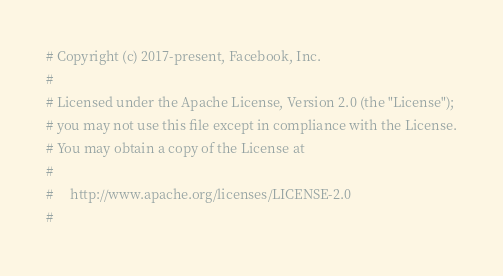<code> <loc_0><loc_0><loc_500><loc_500><_Python_># Copyright (c) 2017-present, Facebook, Inc.
#
# Licensed under the Apache License, Version 2.0 (the "License");
# you may not use this file except in compliance with the License.
# You may obtain a copy of the License at
#
#     http://www.apache.org/licenses/LICENSE-2.0
#</code> 